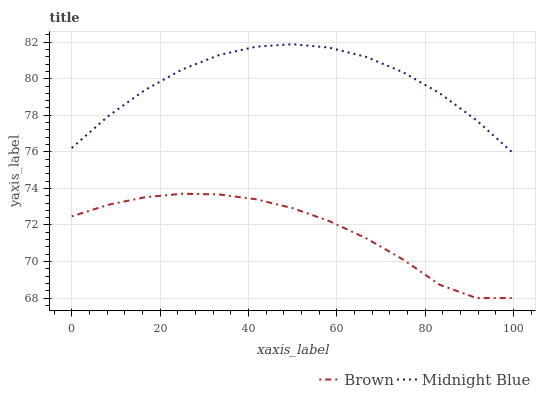Does Brown have the minimum area under the curve?
Answer yes or no. Yes. Does Midnight Blue have the maximum area under the curve?
Answer yes or no. Yes. Does Midnight Blue have the minimum area under the curve?
Answer yes or no. No. Is Brown the smoothest?
Answer yes or no. Yes. Is Midnight Blue the roughest?
Answer yes or no. Yes. Is Midnight Blue the smoothest?
Answer yes or no. No. Does Midnight Blue have the lowest value?
Answer yes or no. No. Does Midnight Blue have the highest value?
Answer yes or no. Yes. Is Brown less than Midnight Blue?
Answer yes or no. Yes. Is Midnight Blue greater than Brown?
Answer yes or no. Yes. Does Brown intersect Midnight Blue?
Answer yes or no. No. 